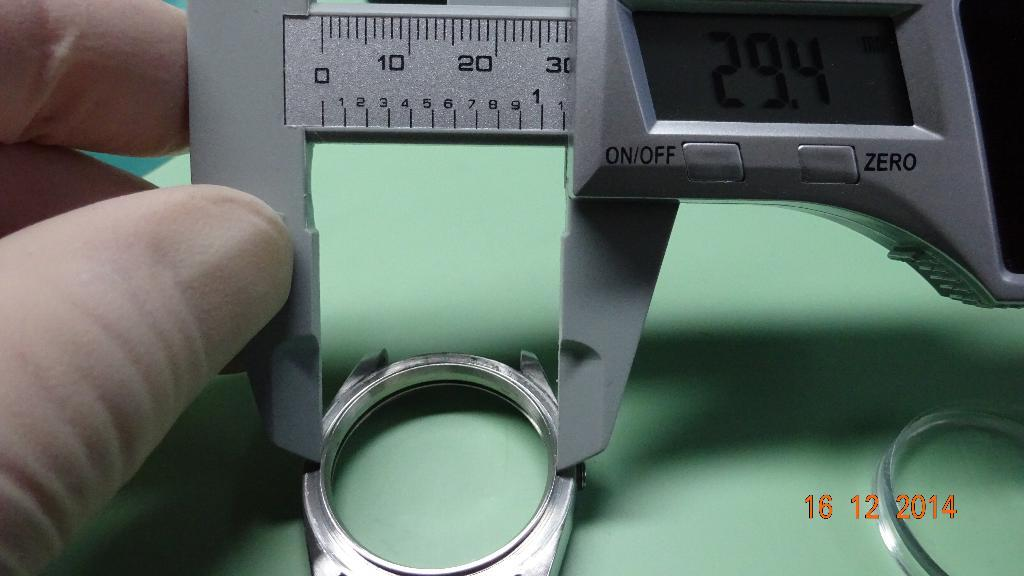Provide a one-sentence caption for the provided image. A person is holding a measuring device that has an on/off switch. 